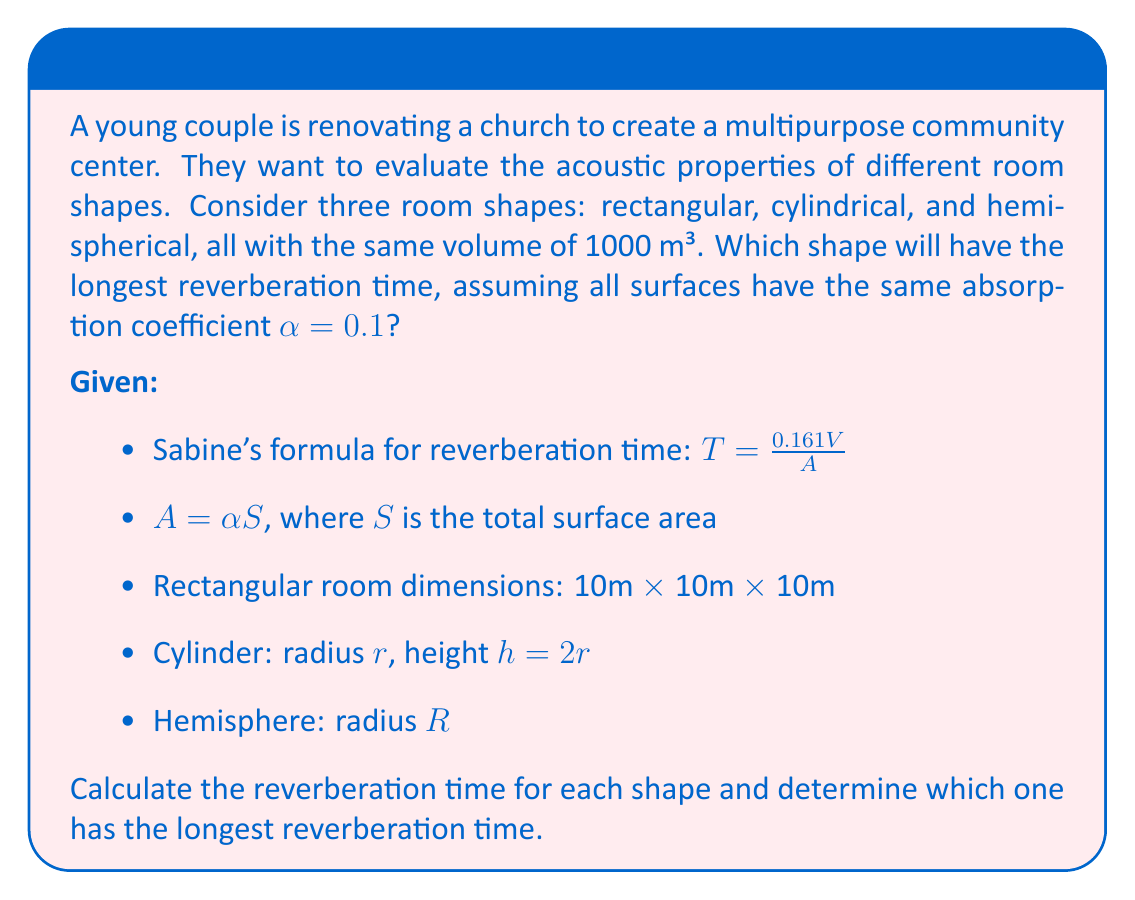What is the answer to this math problem? To solve this problem, we need to calculate the reverberation time for each shape using Sabine's formula and compare the results. Let's go through each shape step by step:

1. Rectangular room:
   Volume: $V = 10 \times 10 \times 10 = 1000$ m³
   Surface area: $S = 2(10 \times 10 + 10 \times 10 + 10 \times 10) = 600$ m²
   $A = \alpha S = 0.1 \times 600 = 60$ m²
   Reverberation time: $T_r = \frac{0.161 \times 1000}{60} = 2.68$ seconds

2. Cylindrical room:
   Volume: $V = \pi r^2 h = \pi r^2 (2r) = 2\pi r^3 = 1000$ m³
   Solving for r: $r = \sqrt[3]{\frac{1000}{2\pi}} \approx 5.42$ m
   Surface area: $S = 2\pi r^2 + 2\pi rh = 2\pi r^2 + 4\pi r^2 = 6\pi r^2 \approx 554.6$ m²
   $A = \alpha S = 0.1 \times 554.6 = 55.46$ m²
   Reverberation time: $T_c = \frac{0.161 \times 1000}{55.46} = 2.90$ seconds

3. Hemispherical room:
   Volume: $V = \frac{2}{3}\pi R^3 = 1000$ m³
   Solving for R: $R = \sqrt[3]{\frac{3000}{2\pi}} \approx 8.92$ m
   Surface area: $S = 2\pi R^2 = 2\pi \times 8.92^2 \approx 500.3$ m²
   $A = \alpha S = 0.1 \times 500.3 = 50.03$ m²
   Reverberation time: $T_h = \frac{0.161 \times 1000}{50.03} = 3.22$ seconds

Comparing the reverberation times:
$T_r = 2.68$ s
$T_c = 2.90$ s
$T_h = 3.22$ s

The hemispherical room has the longest reverberation time.
Answer: The hemispherical room shape has the longest reverberation time of 3.22 seconds. 